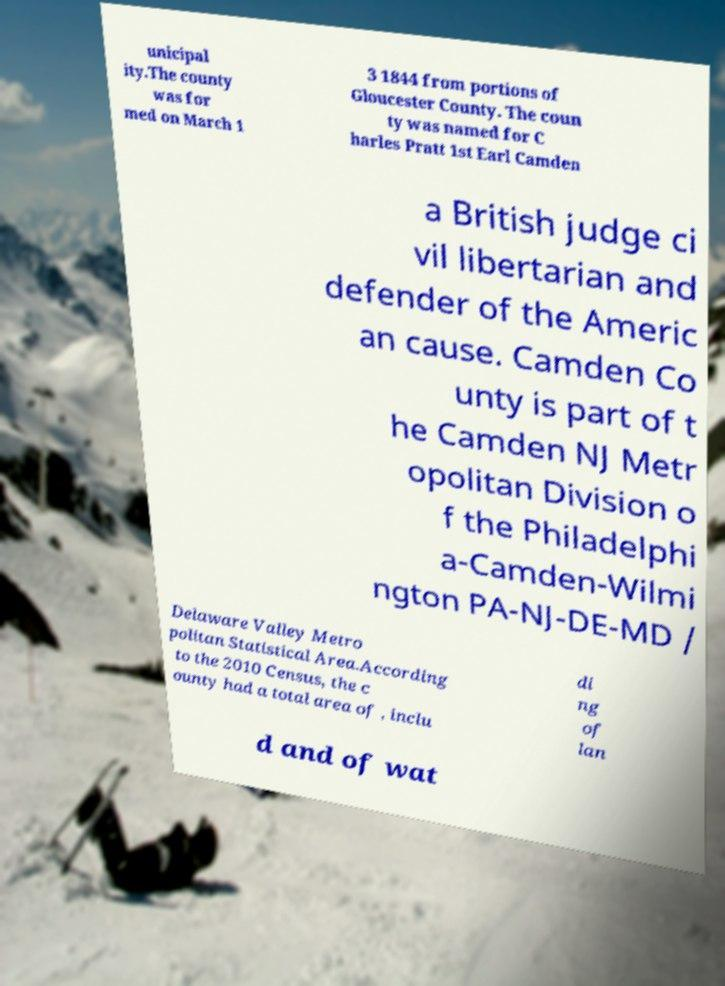Please identify and transcribe the text found in this image. unicipal ity.The county was for med on March 1 3 1844 from portions of Gloucester County. The coun ty was named for C harles Pratt 1st Earl Camden a British judge ci vil libertarian and defender of the Americ an cause. Camden Co unty is part of t he Camden NJ Metr opolitan Division o f the Philadelphi a-Camden-Wilmi ngton PA-NJ-DE-MD / Delaware Valley Metro politan Statistical Area.According to the 2010 Census, the c ounty had a total area of , inclu di ng of lan d and of wat 